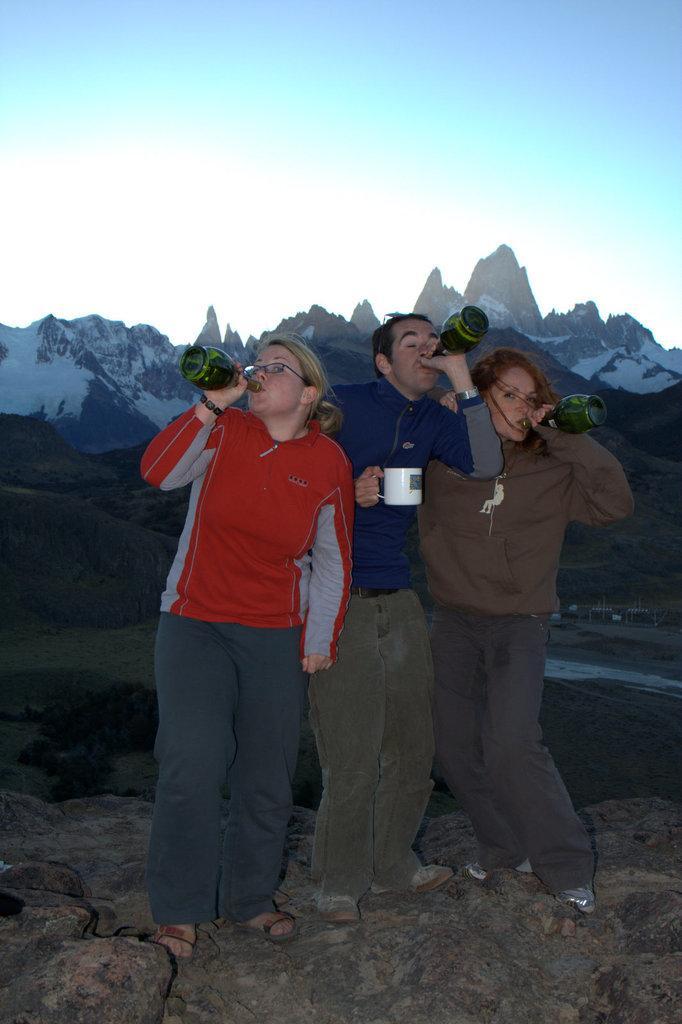Describe this image in one or two sentences. In this picture I can see there are three people standing and there is a man standing between women. They are drinking wine from the wine bottles, there are rocks on the floor. In the backdrop, there are a few mountains in the backdrop, they are covered with snow. 